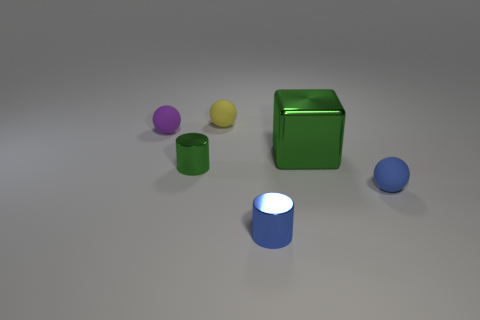What number of small rubber spheres are there?
Your answer should be very brief. 3. Is there a blue rubber sphere of the same size as the yellow sphere?
Your response must be concise. Yes. Does the purple thing have the same material as the sphere right of the large shiny thing?
Make the answer very short. Yes. There is a tiny thing behind the small purple matte object; what material is it?
Your answer should be very brief. Rubber. What is the size of the purple thing?
Your response must be concise. Small. Is the size of the green thing to the right of the small blue metallic thing the same as the rubber ball that is in front of the purple matte thing?
Offer a terse response. No. What is the size of the yellow object that is the same shape as the purple rubber object?
Give a very brief answer. Small. There is a blue rubber object; is it the same size as the shiny object that is behind the green shiny cylinder?
Your answer should be compact. No. Are there any things that are right of the tiny metal thing in front of the small blue ball?
Keep it short and to the point. Yes. What shape is the blue object to the right of the tiny blue cylinder?
Offer a terse response. Sphere. 